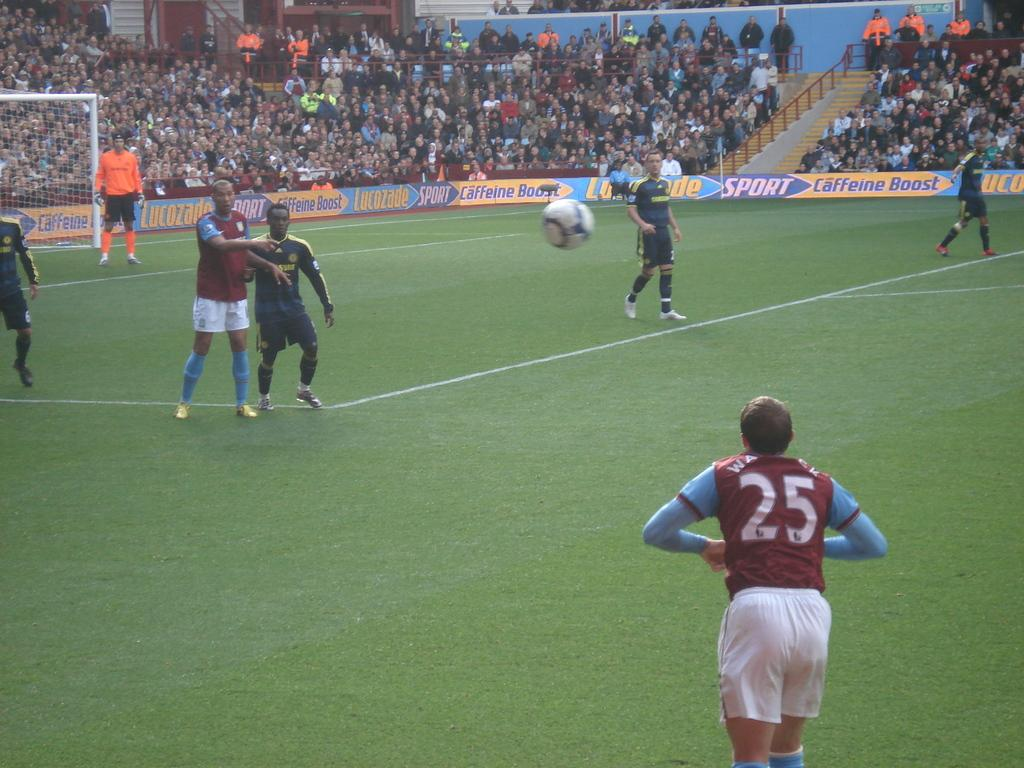<image>
Create a compact narrative representing the image presented. a man in number 25 jersey throws a ball onto the pitch 